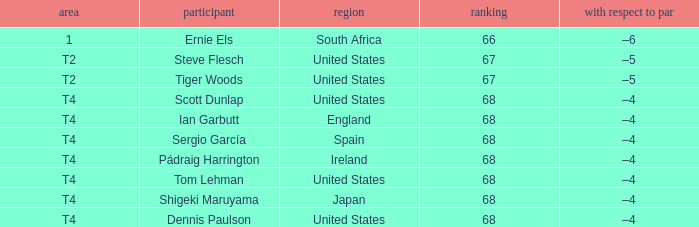What is T2 Place Player Steve Flesch's Score? 67.0. 